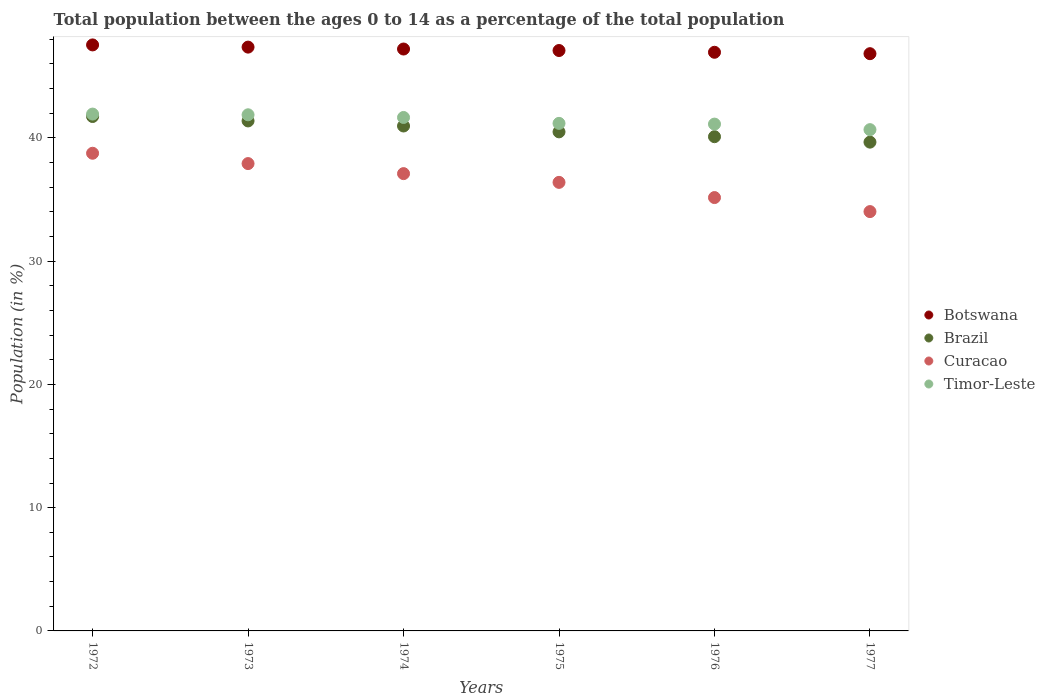Is the number of dotlines equal to the number of legend labels?
Keep it short and to the point. Yes. What is the percentage of the population ages 0 to 14 in Curacao in 1972?
Offer a terse response. 38.75. Across all years, what is the maximum percentage of the population ages 0 to 14 in Botswana?
Your response must be concise. 47.54. Across all years, what is the minimum percentage of the population ages 0 to 14 in Timor-Leste?
Your response must be concise. 40.67. In which year was the percentage of the population ages 0 to 14 in Botswana minimum?
Your answer should be compact. 1977. What is the total percentage of the population ages 0 to 14 in Botswana in the graph?
Provide a succinct answer. 282.98. What is the difference between the percentage of the population ages 0 to 14 in Botswana in 1973 and that in 1974?
Offer a very short reply. 0.16. What is the difference between the percentage of the population ages 0 to 14 in Botswana in 1972 and the percentage of the population ages 0 to 14 in Curacao in 1977?
Give a very brief answer. 13.52. What is the average percentage of the population ages 0 to 14 in Timor-Leste per year?
Make the answer very short. 41.4. In the year 1977, what is the difference between the percentage of the population ages 0 to 14 in Brazil and percentage of the population ages 0 to 14 in Timor-Leste?
Provide a short and direct response. -1.01. In how many years, is the percentage of the population ages 0 to 14 in Curacao greater than 22?
Give a very brief answer. 6. What is the ratio of the percentage of the population ages 0 to 14 in Timor-Leste in 1974 to that in 1976?
Give a very brief answer. 1.01. Is the percentage of the population ages 0 to 14 in Brazil in 1974 less than that in 1977?
Offer a terse response. No. Is the difference between the percentage of the population ages 0 to 14 in Brazil in 1972 and 1974 greater than the difference between the percentage of the population ages 0 to 14 in Timor-Leste in 1972 and 1974?
Give a very brief answer. Yes. What is the difference between the highest and the second highest percentage of the population ages 0 to 14 in Timor-Leste?
Keep it short and to the point. 0.06. What is the difference between the highest and the lowest percentage of the population ages 0 to 14 in Curacao?
Your response must be concise. 4.73. Is the sum of the percentage of the population ages 0 to 14 in Curacao in 1974 and 1977 greater than the maximum percentage of the population ages 0 to 14 in Botswana across all years?
Ensure brevity in your answer.  Yes. Is it the case that in every year, the sum of the percentage of the population ages 0 to 14 in Brazil and percentage of the population ages 0 to 14 in Botswana  is greater than the sum of percentage of the population ages 0 to 14 in Curacao and percentage of the population ages 0 to 14 in Timor-Leste?
Your response must be concise. Yes. Is it the case that in every year, the sum of the percentage of the population ages 0 to 14 in Brazil and percentage of the population ages 0 to 14 in Botswana  is greater than the percentage of the population ages 0 to 14 in Timor-Leste?
Make the answer very short. Yes. Does the percentage of the population ages 0 to 14 in Botswana monotonically increase over the years?
Provide a short and direct response. No. Is the percentage of the population ages 0 to 14 in Botswana strictly greater than the percentage of the population ages 0 to 14 in Curacao over the years?
Your answer should be compact. Yes. Is the percentage of the population ages 0 to 14 in Brazil strictly less than the percentage of the population ages 0 to 14 in Curacao over the years?
Give a very brief answer. No. What is the difference between two consecutive major ticks on the Y-axis?
Make the answer very short. 10. Are the values on the major ticks of Y-axis written in scientific E-notation?
Your answer should be very brief. No. Does the graph contain any zero values?
Your response must be concise. No. What is the title of the graph?
Offer a very short reply. Total population between the ages 0 to 14 as a percentage of the total population. Does "Uganda" appear as one of the legend labels in the graph?
Make the answer very short. No. What is the Population (in %) of Botswana in 1972?
Give a very brief answer. 47.54. What is the Population (in %) in Brazil in 1972?
Your answer should be very brief. 41.73. What is the Population (in %) of Curacao in 1972?
Your answer should be very brief. 38.75. What is the Population (in %) of Timor-Leste in 1972?
Your answer should be very brief. 41.93. What is the Population (in %) of Botswana in 1973?
Give a very brief answer. 47.36. What is the Population (in %) in Brazil in 1973?
Make the answer very short. 41.38. What is the Population (in %) of Curacao in 1973?
Ensure brevity in your answer.  37.92. What is the Population (in %) of Timor-Leste in 1973?
Give a very brief answer. 41.87. What is the Population (in %) in Botswana in 1974?
Make the answer very short. 47.21. What is the Population (in %) in Brazil in 1974?
Keep it short and to the point. 40.97. What is the Population (in %) of Curacao in 1974?
Make the answer very short. 37.1. What is the Population (in %) in Timor-Leste in 1974?
Your response must be concise. 41.66. What is the Population (in %) of Botswana in 1975?
Offer a very short reply. 47.09. What is the Population (in %) in Brazil in 1975?
Make the answer very short. 40.49. What is the Population (in %) in Curacao in 1975?
Your answer should be compact. 36.39. What is the Population (in %) in Timor-Leste in 1975?
Provide a succinct answer. 41.18. What is the Population (in %) of Botswana in 1976?
Provide a short and direct response. 46.95. What is the Population (in %) in Brazil in 1976?
Your answer should be very brief. 40.1. What is the Population (in %) in Curacao in 1976?
Give a very brief answer. 35.16. What is the Population (in %) of Timor-Leste in 1976?
Provide a short and direct response. 41.12. What is the Population (in %) of Botswana in 1977?
Your answer should be very brief. 46.83. What is the Population (in %) of Brazil in 1977?
Offer a terse response. 39.65. What is the Population (in %) in Curacao in 1977?
Offer a very short reply. 34.02. What is the Population (in %) of Timor-Leste in 1977?
Offer a terse response. 40.67. Across all years, what is the maximum Population (in %) in Botswana?
Make the answer very short. 47.54. Across all years, what is the maximum Population (in %) of Brazil?
Your response must be concise. 41.73. Across all years, what is the maximum Population (in %) of Curacao?
Make the answer very short. 38.75. Across all years, what is the maximum Population (in %) in Timor-Leste?
Provide a short and direct response. 41.93. Across all years, what is the minimum Population (in %) of Botswana?
Your response must be concise. 46.83. Across all years, what is the minimum Population (in %) in Brazil?
Your answer should be compact. 39.65. Across all years, what is the minimum Population (in %) of Curacao?
Keep it short and to the point. 34.02. Across all years, what is the minimum Population (in %) in Timor-Leste?
Ensure brevity in your answer.  40.67. What is the total Population (in %) of Botswana in the graph?
Keep it short and to the point. 282.98. What is the total Population (in %) of Brazil in the graph?
Make the answer very short. 244.32. What is the total Population (in %) of Curacao in the graph?
Your answer should be compact. 219.34. What is the total Population (in %) of Timor-Leste in the graph?
Ensure brevity in your answer.  248.42. What is the difference between the Population (in %) of Botswana in 1972 and that in 1973?
Keep it short and to the point. 0.18. What is the difference between the Population (in %) in Brazil in 1972 and that in 1973?
Ensure brevity in your answer.  0.36. What is the difference between the Population (in %) in Curacao in 1972 and that in 1973?
Ensure brevity in your answer.  0.84. What is the difference between the Population (in %) in Timor-Leste in 1972 and that in 1973?
Provide a short and direct response. 0.06. What is the difference between the Population (in %) in Botswana in 1972 and that in 1974?
Your response must be concise. 0.33. What is the difference between the Population (in %) in Brazil in 1972 and that in 1974?
Make the answer very short. 0.77. What is the difference between the Population (in %) of Curacao in 1972 and that in 1974?
Offer a terse response. 1.65. What is the difference between the Population (in %) in Timor-Leste in 1972 and that in 1974?
Make the answer very short. 0.27. What is the difference between the Population (in %) of Botswana in 1972 and that in 1975?
Provide a succinct answer. 0.45. What is the difference between the Population (in %) in Brazil in 1972 and that in 1975?
Provide a succinct answer. 1.24. What is the difference between the Population (in %) of Curacao in 1972 and that in 1975?
Your response must be concise. 2.36. What is the difference between the Population (in %) in Timor-Leste in 1972 and that in 1975?
Make the answer very short. 0.75. What is the difference between the Population (in %) of Botswana in 1972 and that in 1976?
Provide a short and direct response. 0.6. What is the difference between the Population (in %) of Brazil in 1972 and that in 1976?
Your response must be concise. 1.64. What is the difference between the Population (in %) in Curacao in 1972 and that in 1976?
Make the answer very short. 3.6. What is the difference between the Population (in %) in Timor-Leste in 1972 and that in 1976?
Provide a short and direct response. 0.81. What is the difference between the Population (in %) of Botswana in 1972 and that in 1977?
Ensure brevity in your answer.  0.71. What is the difference between the Population (in %) of Brazil in 1972 and that in 1977?
Keep it short and to the point. 2.08. What is the difference between the Population (in %) of Curacao in 1972 and that in 1977?
Give a very brief answer. 4.73. What is the difference between the Population (in %) of Timor-Leste in 1972 and that in 1977?
Provide a succinct answer. 1.26. What is the difference between the Population (in %) of Botswana in 1973 and that in 1974?
Give a very brief answer. 0.16. What is the difference between the Population (in %) of Brazil in 1973 and that in 1974?
Keep it short and to the point. 0.41. What is the difference between the Population (in %) of Curacao in 1973 and that in 1974?
Make the answer very short. 0.81. What is the difference between the Population (in %) in Timor-Leste in 1973 and that in 1974?
Provide a succinct answer. 0.22. What is the difference between the Population (in %) in Botswana in 1973 and that in 1975?
Provide a short and direct response. 0.28. What is the difference between the Population (in %) in Brazil in 1973 and that in 1975?
Provide a succinct answer. 0.89. What is the difference between the Population (in %) in Curacao in 1973 and that in 1975?
Offer a terse response. 1.52. What is the difference between the Population (in %) in Timor-Leste in 1973 and that in 1975?
Keep it short and to the point. 0.7. What is the difference between the Population (in %) of Botswana in 1973 and that in 1976?
Your response must be concise. 0.42. What is the difference between the Population (in %) of Brazil in 1973 and that in 1976?
Make the answer very short. 1.28. What is the difference between the Population (in %) of Curacao in 1973 and that in 1976?
Provide a succinct answer. 2.76. What is the difference between the Population (in %) of Timor-Leste in 1973 and that in 1976?
Keep it short and to the point. 0.76. What is the difference between the Population (in %) of Botswana in 1973 and that in 1977?
Provide a short and direct response. 0.53. What is the difference between the Population (in %) of Brazil in 1973 and that in 1977?
Your answer should be compact. 1.72. What is the difference between the Population (in %) in Curacao in 1973 and that in 1977?
Provide a succinct answer. 3.9. What is the difference between the Population (in %) of Timor-Leste in 1973 and that in 1977?
Keep it short and to the point. 1.21. What is the difference between the Population (in %) of Botswana in 1974 and that in 1975?
Make the answer very short. 0.12. What is the difference between the Population (in %) of Brazil in 1974 and that in 1975?
Provide a succinct answer. 0.48. What is the difference between the Population (in %) in Curacao in 1974 and that in 1975?
Ensure brevity in your answer.  0.71. What is the difference between the Population (in %) of Timor-Leste in 1974 and that in 1975?
Your response must be concise. 0.48. What is the difference between the Population (in %) of Botswana in 1974 and that in 1976?
Keep it short and to the point. 0.26. What is the difference between the Population (in %) in Brazil in 1974 and that in 1976?
Provide a short and direct response. 0.87. What is the difference between the Population (in %) of Curacao in 1974 and that in 1976?
Keep it short and to the point. 1.94. What is the difference between the Population (in %) in Timor-Leste in 1974 and that in 1976?
Offer a terse response. 0.54. What is the difference between the Population (in %) of Botswana in 1974 and that in 1977?
Your answer should be compact. 0.38. What is the difference between the Population (in %) of Brazil in 1974 and that in 1977?
Offer a terse response. 1.31. What is the difference between the Population (in %) of Curacao in 1974 and that in 1977?
Offer a very short reply. 3.08. What is the difference between the Population (in %) of Botswana in 1975 and that in 1976?
Offer a very short reply. 0.14. What is the difference between the Population (in %) of Brazil in 1975 and that in 1976?
Give a very brief answer. 0.39. What is the difference between the Population (in %) of Curacao in 1975 and that in 1976?
Give a very brief answer. 1.23. What is the difference between the Population (in %) in Timor-Leste in 1975 and that in 1976?
Provide a short and direct response. 0.06. What is the difference between the Population (in %) in Botswana in 1975 and that in 1977?
Offer a very short reply. 0.26. What is the difference between the Population (in %) of Brazil in 1975 and that in 1977?
Offer a terse response. 0.83. What is the difference between the Population (in %) in Curacao in 1975 and that in 1977?
Your answer should be very brief. 2.37. What is the difference between the Population (in %) in Timor-Leste in 1975 and that in 1977?
Keep it short and to the point. 0.51. What is the difference between the Population (in %) in Botswana in 1976 and that in 1977?
Offer a very short reply. 0.11. What is the difference between the Population (in %) of Brazil in 1976 and that in 1977?
Offer a terse response. 0.44. What is the difference between the Population (in %) of Curacao in 1976 and that in 1977?
Ensure brevity in your answer.  1.14. What is the difference between the Population (in %) of Timor-Leste in 1976 and that in 1977?
Provide a succinct answer. 0.45. What is the difference between the Population (in %) of Botswana in 1972 and the Population (in %) of Brazil in 1973?
Make the answer very short. 6.17. What is the difference between the Population (in %) in Botswana in 1972 and the Population (in %) in Curacao in 1973?
Provide a succinct answer. 9.63. What is the difference between the Population (in %) in Botswana in 1972 and the Population (in %) in Timor-Leste in 1973?
Make the answer very short. 5.67. What is the difference between the Population (in %) in Brazil in 1972 and the Population (in %) in Curacao in 1973?
Provide a succinct answer. 3.82. What is the difference between the Population (in %) in Brazil in 1972 and the Population (in %) in Timor-Leste in 1973?
Offer a terse response. -0.14. What is the difference between the Population (in %) in Curacao in 1972 and the Population (in %) in Timor-Leste in 1973?
Provide a short and direct response. -3.12. What is the difference between the Population (in %) of Botswana in 1972 and the Population (in %) of Brazil in 1974?
Offer a very short reply. 6.58. What is the difference between the Population (in %) of Botswana in 1972 and the Population (in %) of Curacao in 1974?
Provide a succinct answer. 10.44. What is the difference between the Population (in %) in Botswana in 1972 and the Population (in %) in Timor-Leste in 1974?
Provide a short and direct response. 5.89. What is the difference between the Population (in %) of Brazil in 1972 and the Population (in %) of Curacao in 1974?
Give a very brief answer. 4.63. What is the difference between the Population (in %) of Brazil in 1972 and the Population (in %) of Timor-Leste in 1974?
Provide a succinct answer. 0.08. What is the difference between the Population (in %) of Curacao in 1972 and the Population (in %) of Timor-Leste in 1974?
Offer a very short reply. -2.9. What is the difference between the Population (in %) in Botswana in 1972 and the Population (in %) in Brazil in 1975?
Keep it short and to the point. 7.05. What is the difference between the Population (in %) of Botswana in 1972 and the Population (in %) of Curacao in 1975?
Offer a terse response. 11.15. What is the difference between the Population (in %) in Botswana in 1972 and the Population (in %) in Timor-Leste in 1975?
Keep it short and to the point. 6.37. What is the difference between the Population (in %) in Brazil in 1972 and the Population (in %) in Curacao in 1975?
Your answer should be very brief. 5.34. What is the difference between the Population (in %) of Brazil in 1972 and the Population (in %) of Timor-Leste in 1975?
Ensure brevity in your answer.  0.56. What is the difference between the Population (in %) of Curacao in 1972 and the Population (in %) of Timor-Leste in 1975?
Keep it short and to the point. -2.42. What is the difference between the Population (in %) in Botswana in 1972 and the Population (in %) in Brazil in 1976?
Ensure brevity in your answer.  7.45. What is the difference between the Population (in %) in Botswana in 1972 and the Population (in %) in Curacao in 1976?
Offer a terse response. 12.39. What is the difference between the Population (in %) in Botswana in 1972 and the Population (in %) in Timor-Leste in 1976?
Offer a terse response. 6.42. What is the difference between the Population (in %) of Brazil in 1972 and the Population (in %) of Curacao in 1976?
Provide a short and direct response. 6.58. What is the difference between the Population (in %) of Brazil in 1972 and the Population (in %) of Timor-Leste in 1976?
Give a very brief answer. 0.62. What is the difference between the Population (in %) of Curacao in 1972 and the Population (in %) of Timor-Leste in 1976?
Give a very brief answer. -2.37. What is the difference between the Population (in %) in Botswana in 1972 and the Population (in %) in Brazil in 1977?
Your response must be concise. 7.89. What is the difference between the Population (in %) in Botswana in 1972 and the Population (in %) in Curacao in 1977?
Your response must be concise. 13.52. What is the difference between the Population (in %) of Botswana in 1972 and the Population (in %) of Timor-Leste in 1977?
Provide a succinct answer. 6.88. What is the difference between the Population (in %) of Brazil in 1972 and the Population (in %) of Curacao in 1977?
Give a very brief answer. 7.71. What is the difference between the Population (in %) in Brazil in 1972 and the Population (in %) in Timor-Leste in 1977?
Your answer should be compact. 1.07. What is the difference between the Population (in %) in Curacao in 1972 and the Population (in %) in Timor-Leste in 1977?
Provide a short and direct response. -1.91. What is the difference between the Population (in %) of Botswana in 1973 and the Population (in %) of Brazil in 1974?
Provide a succinct answer. 6.4. What is the difference between the Population (in %) in Botswana in 1973 and the Population (in %) in Curacao in 1974?
Your response must be concise. 10.26. What is the difference between the Population (in %) of Botswana in 1973 and the Population (in %) of Timor-Leste in 1974?
Keep it short and to the point. 5.71. What is the difference between the Population (in %) of Brazil in 1973 and the Population (in %) of Curacao in 1974?
Make the answer very short. 4.28. What is the difference between the Population (in %) in Brazil in 1973 and the Population (in %) in Timor-Leste in 1974?
Give a very brief answer. -0.28. What is the difference between the Population (in %) of Curacao in 1973 and the Population (in %) of Timor-Leste in 1974?
Your response must be concise. -3.74. What is the difference between the Population (in %) in Botswana in 1973 and the Population (in %) in Brazil in 1975?
Keep it short and to the point. 6.88. What is the difference between the Population (in %) in Botswana in 1973 and the Population (in %) in Curacao in 1975?
Provide a succinct answer. 10.97. What is the difference between the Population (in %) of Botswana in 1973 and the Population (in %) of Timor-Leste in 1975?
Offer a very short reply. 6.19. What is the difference between the Population (in %) in Brazil in 1973 and the Population (in %) in Curacao in 1975?
Make the answer very short. 4.99. What is the difference between the Population (in %) of Brazil in 1973 and the Population (in %) of Timor-Leste in 1975?
Provide a succinct answer. 0.2. What is the difference between the Population (in %) of Curacao in 1973 and the Population (in %) of Timor-Leste in 1975?
Give a very brief answer. -3.26. What is the difference between the Population (in %) in Botswana in 1973 and the Population (in %) in Brazil in 1976?
Provide a succinct answer. 7.27. What is the difference between the Population (in %) of Botswana in 1973 and the Population (in %) of Curacao in 1976?
Offer a very short reply. 12.21. What is the difference between the Population (in %) in Botswana in 1973 and the Population (in %) in Timor-Leste in 1976?
Your answer should be very brief. 6.25. What is the difference between the Population (in %) of Brazil in 1973 and the Population (in %) of Curacao in 1976?
Ensure brevity in your answer.  6.22. What is the difference between the Population (in %) in Brazil in 1973 and the Population (in %) in Timor-Leste in 1976?
Keep it short and to the point. 0.26. What is the difference between the Population (in %) of Curacao in 1973 and the Population (in %) of Timor-Leste in 1976?
Offer a terse response. -3.2. What is the difference between the Population (in %) in Botswana in 1973 and the Population (in %) in Brazil in 1977?
Your answer should be very brief. 7.71. What is the difference between the Population (in %) of Botswana in 1973 and the Population (in %) of Curacao in 1977?
Your answer should be very brief. 13.34. What is the difference between the Population (in %) in Botswana in 1973 and the Population (in %) in Timor-Leste in 1977?
Your response must be concise. 6.7. What is the difference between the Population (in %) of Brazil in 1973 and the Population (in %) of Curacao in 1977?
Ensure brevity in your answer.  7.36. What is the difference between the Population (in %) of Brazil in 1973 and the Population (in %) of Timor-Leste in 1977?
Ensure brevity in your answer.  0.71. What is the difference between the Population (in %) in Curacao in 1973 and the Population (in %) in Timor-Leste in 1977?
Ensure brevity in your answer.  -2.75. What is the difference between the Population (in %) of Botswana in 1974 and the Population (in %) of Brazil in 1975?
Make the answer very short. 6.72. What is the difference between the Population (in %) of Botswana in 1974 and the Population (in %) of Curacao in 1975?
Provide a succinct answer. 10.82. What is the difference between the Population (in %) in Botswana in 1974 and the Population (in %) in Timor-Leste in 1975?
Provide a succinct answer. 6.03. What is the difference between the Population (in %) of Brazil in 1974 and the Population (in %) of Curacao in 1975?
Offer a terse response. 4.57. What is the difference between the Population (in %) in Brazil in 1974 and the Population (in %) in Timor-Leste in 1975?
Provide a short and direct response. -0.21. What is the difference between the Population (in %) in Curacao in 1974 and the Population (in %) in Timor-Leste in 1975?
Offer a very short reply. -4.08. What is the difference between the Population (in %) of Botswana in 1974 and the Population (in %) of Brazil in 1976?
Make the answer very short. 7.11. What is the difference between the Population (in %) of Botswana in 1974 and the Population (in %) of Curacao in 1976?
Your answer should be very brief. 12.05. What is the difference between the Population (in %) of Botswana in 1974 and the Population (in %) of Timor-Leste in 1976?
Make the answer very short. 6.09. What is the difference between the Population (in %) in Brazil in 1974 and the Population (in %) in Curacao in 1976?
Your response must be concise. 5.81. What is the difference between the Population (in %) of Brazil in 1974 and the Population (in %) of Timor-Leste in 1976?
Offer a terse response. -0.15. What is the difference between the Population (in %) in Curacao in 1974 and the Population (in %) in Timor-Leste in 1976?
Offer a very short reply. -4.02. What is the difference between the Population (in %) of Botswana in 1974 and the Population (in %) of Brazil in 1977?
Offer a very short reply. 7.55. What is the difference between the Population (in %) of Botswana in 1974 and the Population (in %) of Curacao in 1977?
Your answer should be compact. 13.19. What is the difference between the Population (in %) of Botswana in 1974 and the Population (in %) of Timor-Leste in 1977?
Offer a terse response. 6.54. What is the difference between the Population (in %) of Brazil in 1974 and the Population (in %) of Curacao in 1977?
Offer a very short reply. 6.95. What is the difference between the Population (in %) of Brazil in 1974 and the Population (in %) of Timor-Leste in 1977?
Your answer should be very brief. 0.3. What is the difference between the Population (in %) of Curacao in 1974 and the Population (in %) of Timor-Leste in 1977?
Your answer should be compact. -3.57. What is the difference between the Population (in %) in Botswana in 1975 and the Population (in %) in Brazil in 1976?
Make the answer very short. 6.99. What is the difference between the Population (in %) of Botswana in 1975 and the Population (in %) of Curacao in 1976?
Offer a terse response. 11.93. What is the difference between the Population (in %) in Botswana in 1975 and the Population (in %) in Timor-Leste in 1976?
Your response must be concise. 5.97. What is the difference between the Population (in %) in Brazil in 1975 and the Population (in %) in Curacao in 1976?
Offer a very short reply. 5.33. What is the difference between the Population (in %) of Brazil in 1975 and the Population (in %) of Timor-Leste in 1976?
Your response must be concise. -0.63. What is the difference between the Population (in %) in Curacao in 1975 and the Population (in %) in Timor-Leste in 1976?
Give a very brief answer. -4.73. What is the difference between the Population (in %) of Botswana in 1975 and the Population (in %) of Brazil in 1977?
Make the answer very short. 7.43. What is the difference between the Population (in %) of Botswana in 1975 and the Population (in %) of Curacao in 1977?
Provide a succinct answer. 13.07. What is the difference between the Population (in %) of Botswana in 1975 and the Population (in %) of Timor-Leste in 1977?
Keep it short and to the point. 6.42. What is the difference between the Population (in %) of Brazil in 1975 and the Population (in %) of Curacao in 1977?
Offer a terse response. 6.47. What is the difference between the Population (in %) in Brazil in 1975 and the Population (in %) in Timor-Leste in 1977?
Provide a short and direct response. -0.18. What is the difference between the Population (in %) in Curacao in 1975 and the Population (in %) in Timor-Leste in 1977?
Your answer should be compact. -4.28. What is the difference between the Population (in %) in Botswana in 1976 and the Population (in %) in Brazil in 1977?
Give a very brief answer. 7.29. What is the difference between the Population (in %) in Botswana in 1976 and the Population (in %) in Curacao in 1977?
Your answer should be very brief. 12.93. What is the difference between the Population (in %) in Botswana in 1976 and the Population (in %) in Timor-Leste in 1977?
Offer a terse response. 6.28. What is the difference between the Population (in %) in Brazil in 1976 and the Population (in %) in Curacao in 1977?
Keep it short and to the point. 6.08. What is the difference between the Population (in %) in Brazil in 1976 and the Population (in %) in Timor-Leste in 1977?
Ensure brevity in your answer.  -0.57. What is the difference between the Population (in %) of Curacao in 1976 and the Population (in %) of Timor-Leste in 1977?
Keep it short and to the point. -5.51. What is the average Population (in %) of Botswana per year?
Provide a short and direct response. 47.16. What is the average Population (in %) of Brazil per year?
Make the answer very short. 40.72. What is the average Population (in %) in Curacao per year?
Offer a terse response. 36.56. What is the average Population (in %) of Timor-Leste per year?
Your answer should be very brief. 41.4. In the year 1972, what is the difference between the Population (in %) of Botswana and Population (in %) of Brazil?
Offer a terse response. 5.81. In the year 1972, what is the difference between the Population (in %) in Botswana and Population (in %) in Curacao?
Make the answer very short. 8.79. In the year 1972, what is the difference between the Population (in %) of Botswana and Population (in %) of Timor-Leste?
Provide a succinct answer. 5.61. In the year 1972, what is the difference between the Population (in %) of Brazil and Population (in %) of Curacao?
Provide a succinct answer. 2.98. In the year 1972, what is the difference between the Population (in %) of Brazil and Population (in %) of Timor-Leste?
Offer a very short reply. -0.2. In the year 1972, what is the difference between the Population (in %) of Curacao and Population (in %) of Timor-Leste?
Provide a short and direct response. -3.18. In the year 1973, what is the difference between the Population (in %) of Botswana and Population (in %) of Brazil?
Your answer should be very brief. 5.99. In the year 1973, what is the difference between the Population (in %) in Botswana and Population (in %) in Curacao?
Offer a very short reply. 9.45. In the year 1973, what is the difference between the Population (in %) of Botswana and Population (in %) of Timor-Leste?
Your answer should be very brief. 5.49. In the year 1973, what is the difference between the Population (in %) of Brazil and Population (in %) of Curacao?
Your response must be concise. 3.46. In the year 1973, what is the difference between the Population (in %) in Brazil and Population (in %) in Timor-Leste?
Provide a succinct answer. -0.5. In the year 1973, what is the difference between the Population (in %) in Curacao and Population (in %) in Timor-Leste?
Ensure brevity in your answer.  -3.96. In the year 1974, what is the difference between the Population (in %) of Botswana and Population (in %) of Brazil?
Your answer should be compact. 6.24. In the year 1974, what is the difference between the Population (in %) in Botswana and Population (in %) in Curacao?
Make the answer very short. 10.11. In the year 1974, what is the difference between the Population (in %) of Botswana and Population (in %) of Timor-Leste?
Provide a succinct answer. 5.55. In the year 1974, what is the difference between the Population (in %) in Brazil and Population (in %) in Curacao?
Your answer should be compact. 3.86. In the year 1974, what is the difference between the Population (in %) in Brazil and Population (in %) in Timor-Leste?
Provide a succinct answer. -0.69. In the year 1974, what is the difference between the Population (in %) in Curacao and Population (in %) in Timor-Leste?
Offer a very short reply. -4.56. In the year 1975, what is the difference between the Population (in %) in Botswana and Population (in %) in Brazil?
Provide a succinct answer. 6.6. In the year 1975, what is the difference between the Population (in %) in Botswana and Population (in %) in Curacao?
Offer a terse response. 10.7. In the year 1975, what is the difference between the Population (in %) in Botswana and Population (in %) in Timor-Leste?
Provide a succinct answer. 5.91. In the year 1975, what is the difference between the Population (in %) in Brazil and Population (in %) in Curacao?
Your answer should be very brief. 4.1. In the year 1975, what is the difference between the Population (in %) of Brazil and Population (in %) of Timor-Leste?
Provide a succinct answer. -0.69. In the year 1975, what is the difference between the Population (in %) in Curacao and Population (in %) in Timor-Leste?
Your answer should be very brief. -4.79. In the year 1976, what is the difference between the Population (in %) in Botswana and Population (in %) in Brazil?
Your answer should be compact. 6.85. In the year 1976, what is the difference between the Population (in %) of Botswana and Population (in %) of Curacao?
Your answer should be compact. 11.79. In the year 1976, what is the difference between the Population (in %) in Botswana and Population (in %) in Timor-Leste?
Your response must be concise. 5.83. In the year 1976, what is the difference between the Population (in %) of Brazil and Population (in %) of Curacao?
Give a very brief answer. 4.94. In the year 1976, what is the difference between the Population (in %) of Brazil and Population (in %) of Timor-Leste?
Keep it short and to the point. -1.02. In the year 1976, what is the difference between the Population (in %) of Curacao and Population (in %) of Timor-Leste?
Your answer should be compact. -5.96. In the year 1977, what is the difference between the Population (in %) of Botswana and Population (in %) of Brazil?
Provide a short and direct response. 7.18. In the year 1977, what is the difference between the Population (in %) of Botswana and Population (in %) of Curacao?
Your answer should be compact. 12.81. In the year 1977, what is the difference between the Population (in %) in Botswana and Population (in %) in Timor-Leste?
Your answer should be compact. 6.16. In the year 1977, what is the difference between the Population (in %) of Brazil and Population (in %) of Curacao?
Offer a terse response. 5.64. In the year 1977, what is the difference between the Population (in %) in Brazil and Population (in %) in Timor-Leste?
Your answer should be very brief. -1.01. In the year 1977, what is the difference between the Population (in %) of Curacao and Population (in %) of Timor-Leste?
Give a very brief answer. -6.65. What is the ratio of the Population (in %) of Brazil in 1972 to that in 1973?
Provide a short and direct response. 1.01. What is the ratio of the Population (in %) of Curacao in 1972 to that in 1973?
Offer a very short reply. 1.02. What is the ratio of the Population (in %) in Botswana in 1972 to that in 1974?
Your answer should be very brief. 1.01. What is the ratio of the Population (in %) of Brazil in 1972 to that in 1974?
Offer a terse response. 1.02. What is the ratio of the Population (in %) in Curacao in 1972 to that in 1974?
Provide a short and direct response. 1.04. What is the ratio of the Population (in %) of Timor-Leste in 1972 to that in 1974?
Provide a succinct answer. 1.01. What is the ratio of the Population (in %) in Botswana in 1972 to that in 1975?
Your answer should be very brief. 1.01. What is the ratio of the Population (in %) of Brazil in 1972 to that in 1975?
Keep it short and to the point. 1.03. What is the ratio of the Population (in %) in Curacao in 1972 to that in 1975?
Provide a short and direct response. 1.06. What is the ratio of the Population (in %) in Timor-Leste in 1972 to that in 1975?
Give a very brief answer. 1.02. What is the ratio of the Population (in %) in Botswana in 1972 to that in 1976?
Provide a short and direct response. 1.01. What is the ratio of the Population (in %) in Brazil in 1972 to that in 1976?
Offer a very short reply. 1.04. What is the ratio of the Population (in %) of Curacao in 1972 to that in 1976?
Give a very brief answer. 1.1. What is the ratio of the Population (in %) in Timor-Leste in 1972 to that in 1976?
Offer a terse response. 1.02. What is the ratio of the Population (in %) in Botswana in 1972 to that in 1977?
Provide a succinct answer. 1.02. What is the ratio of the Population (in %) of Brazil in 1972 to that in 1977?
Offer a very short reply. 1.05. What is the ratio of the Population (in %) of Curacao in 1972 to that in 1977?
Your response must be concise. 1.14. What is the ratio of the Population (in %) of Timor-Leste in 1972 to that in 1977?
Keep it short and to the point. 1.03. What is the ratio of the Population (in %) of Curacao in 1973 to that in 1974?
Offer a terse response. 1.02. What is the ratio of the Population (in %) in Timor-Leste in 1973 to that in 1974?
Your answer should be compact. 1.01. What is the ratio of the Population (in %) of Botswana in 1973 to that in 1975?
Give a very brief answer. 1.01. What is the ratio of the Population (in %) of Brazil in 1973 to that in 1975?
Your answer should be very brief. 1.02. What is the ratio of the Population (in %) of Curacao in 1973 to that in 1975?
Offer a very short reply. 1.04. What is the ratio of the Population (in %) in Timor-Leste in 1973 to that in 1975?
Offer a very short reply. 1.02. What is the ratio of the Population (in %) of Botswana in 1973 to that in 1976?
Your answer should be very brief. 1.01. What is the ratio of the Population (in %) in Brazil in 1973 to that in 1976?
Give a very brief answer. 1.03. What is the ratio of the Population (in %) of Curacao in 1973 to that in 1976?
Provide a succinct answer. 1.08. What is the ratio of the Population (in %) in Timor-Leste in 1973 to that in 1976?
Provide a succinct answer. 1.02. What is the ratio of the Population (in %) of Botswana in 1973 to that in 1977?
Your answer should be very brief. 1.01. What is the ratio of the Population (in %) of Brazil in 1973 to that in 1977?
Keep it short and to the point. 1.04. What is the ratio of the Population (in %) in Curacao in 1973 to that in 1977?
Give a very brief answer. 1.11. What is the ratio of the Population (in %) of Timor-Leste in 1973 to that in 1977?
Your answer should be compact. 1.03. What is the ratio of the Population (in %) of Brazil in 1974 to that in 1975?
Ensure brevity in your answer.  1.01. What is the ratio of the Population (in %) of Curacao in 1974 to that in 1975?
Offer a very short reply. 1.02. What is the ratio of the Population (in %) of Timor-Leste in 1974 to that in 1975?
Give a very brief answer. 1.01. What is the ratio of the Population (in %) in Botswana in 1974 to that in 1976?
Make the answer very short. 1.01. What is the ratio of the Population (in %) in Brazil in 1974 to that in 1976?
Keep it short and to the point. 1.02. What is the ratio of the Population (in %) in Curacao in 1974 to that in 1976?
Keep it short and to the point. 1.06. What is the ratio of the Population (in %) of Timor-Leste in 1974 to that in 1976?
Give a very brief answer. 1.01. What is the ratio of the Population (in %) of Botswana in 1974 to that in 1977?
Keep it short and to the point. 1.01. What is the ratio of the Population (in %) in Brazil in 1974 to that in 1977?
Make the answer very short. 1.03. What is the ratio of the Population (in %) of Curacao in 1974 to that in 1977?
Provide a succinct answer. 1.09. What is the ratio of the Population (in %) of Timor-Leste in 1974 to that in 1977?
Give a very brief answer. 1.02. What is the ratio of the Population (in %) of Botswana in 1975 to that in 1976?
Provide a succinct answer. 1. What is the ratio of the Population (in %) in Brazil in 1975 to that in 1976?
Ensure brevity in your answer.  1.01. What is the ratio of the Population (in %) of Curacao in 1975 to that in 1976?
Keep it short and to the point. 1.04. What is the ratio of the Population (in %) in Brazil in 1975 to that in 1977?
Offer a terse response. 1.02. What is the ratio of the Population (in %) of Curacao in 1975 to that in 1977?
Keep it short and to the point. 1.07. What is the ratio of the Population (in %) of Timor-Leste in 1975 to that in 1977?
Give a very brief answer. 1.01. What is the ratio of the Population (in %) in Brazil in 1976 to that in 1977?
Make the answer very short. 1.01. What is the ratio of the Population (in %) of Curacao in 1976 to that in 1977?
Offer a very short reply. 1.03. What is the ratio of the Population (in %) in Timor-Leste in 1976 to that in 1977?
Provide a short and direct response. 1.01. What is the difference between the highest and the second highest Population (in %) in Botswana?
Make the answer very short. 0.18. What is the difference between the highest and the second highest Population (in %) of Brazil?
Provide a succinct answer. 0.36. What is the difference between the highest and the second highest Population (in %) in Curacao?
Give a very brief answer. 0.84. What is the difference between the highest and the second highest Population (in %) of Timor-Leste?
Keep it short and to the point. 0.06. What is the difference between the highest and the lowest Population (in %) in Botswana?
Keep it short and to the point. 0.71. What is the difference between the highest and the lowest Population (in %) of Brazil?
Provide a short and direct response. 2.08. What is the difference between the highest and the lowest Population (in %) of Curacao?
Offer a terse response. 4.73. What is the difference between the highest and the lowest Population (in %) in Timor-Leste?
Offer a terse response. 1.26. 